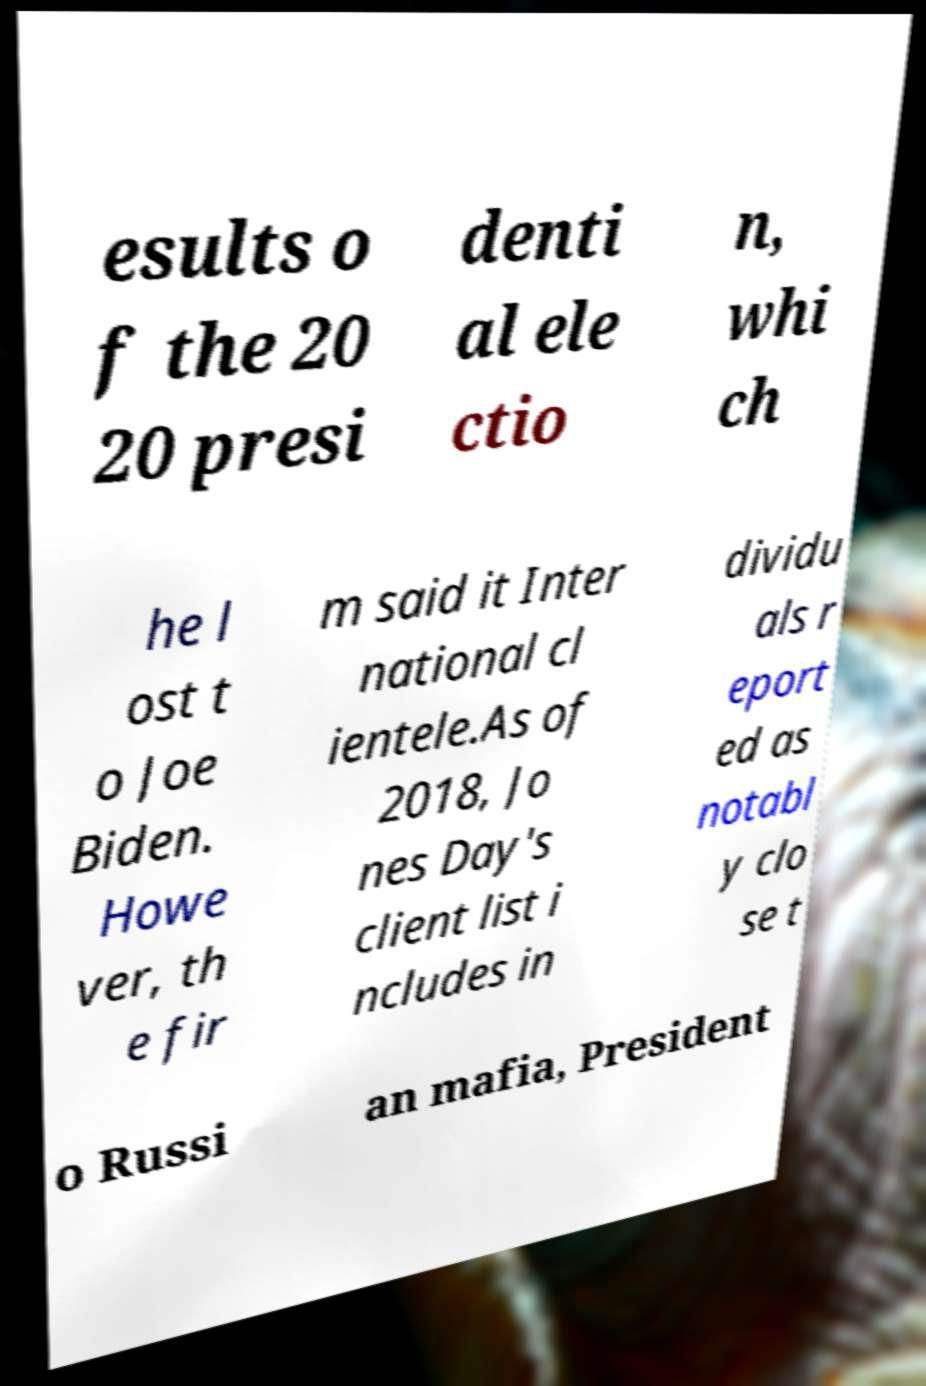Could you extract and type out the text from this image? esults o f the 20 20 presi denti al ele ctio n, whi ch he l ost t o Joe Biden. Howe ver, th e fir m said it Inter national cl ientele.As of 2018, Jo nes Day's client list i ncludes in dividu als r eport ed as notabl y clo se t o Russi an mafia, President 